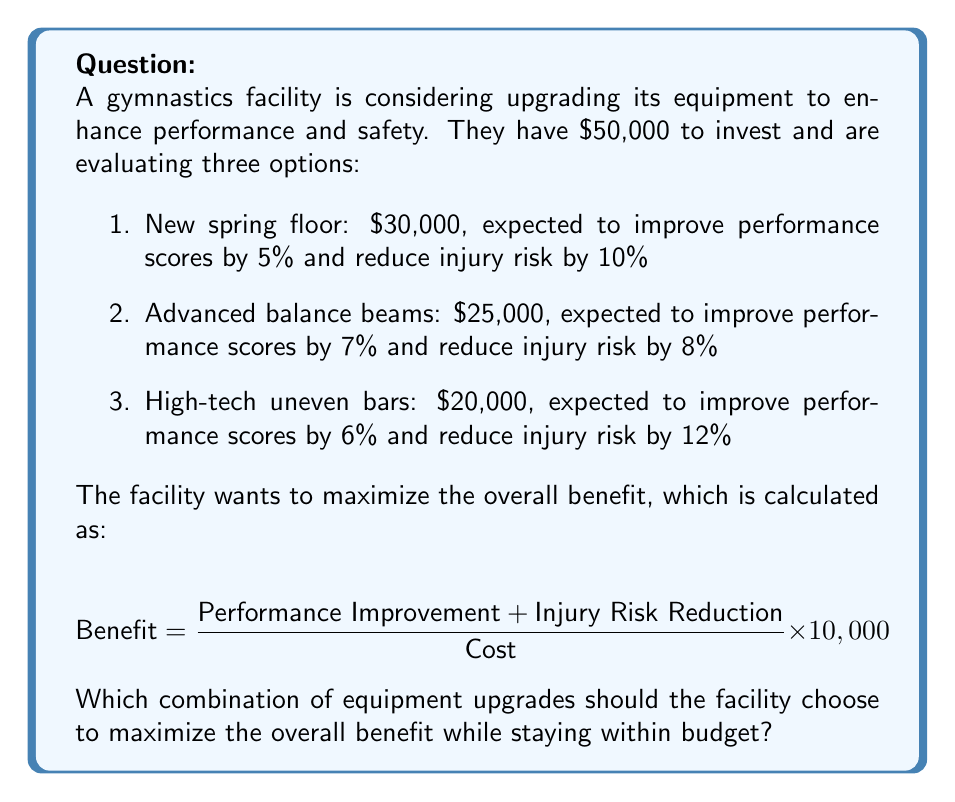What is the answer to this math problem? To solve this problem, we need to evaluate all possible combinations of equipment upgrades that fit within the $50,000 budget and calculate their respective benefits. Let's go through this step-by-step:

1. Identify possible combinations:
   a. Spring floor only
   b. Advanced balance beams only
   c. High-tech uneven bars only
   d. Advanced balance beams + High-tech uneven bars
   e. Spring floor + High-tech uneven bars

2. Calculate the benefit for each combination:

   a. Spring floor only:
   $$ \text{Benefit} = \frac{5\% + 10\%}{30,000} \times 10,000 = 50 $$

   b. Advanced balance beams only:
   $$ \text{Benefit} = \frac{7\% + 8\%}{25,000} \times 10,000 = 60 $$

   c. High-tech uneven bars only:
   $$ \text{Benefit} = \frac{6\% + 12\%}{20,000} \times 10,000 = 90 $$

   d. Advanced balance beams + High-tech uneven bars:
   $$ \text{Benefit} = \frac{(7\% + 8\%) + (6\% + 12\%)}{25,000 + 20,000} \times 10,000 = 73.33 $$

   e. Spring floor + High-tech uneven bars:
   $$ \text{Benefit} = \frac{(5\% + 10\%) + (6\% + 12\%)}{30,000 + 20,000} \times 10,000 = 66 $$

3. Compare the benefits:
   The highest benefit is achieved by purchasing the high-tech uneven bars only, with a benefit score of 90.

4. Check the budget constraint:
   The high-tech uneven bars cost $20,000, which is within the $50,000 budget.

Therefore, the optimal choice to maximize the overall benefit while staying within budget is to purchase the high-tech uneven bars.
Answer: The facility should choose to upgrade to the high-tech uneven bars, which provides the highest benefit score of 90 and costs $20,000, well within the $50,000 budget. 